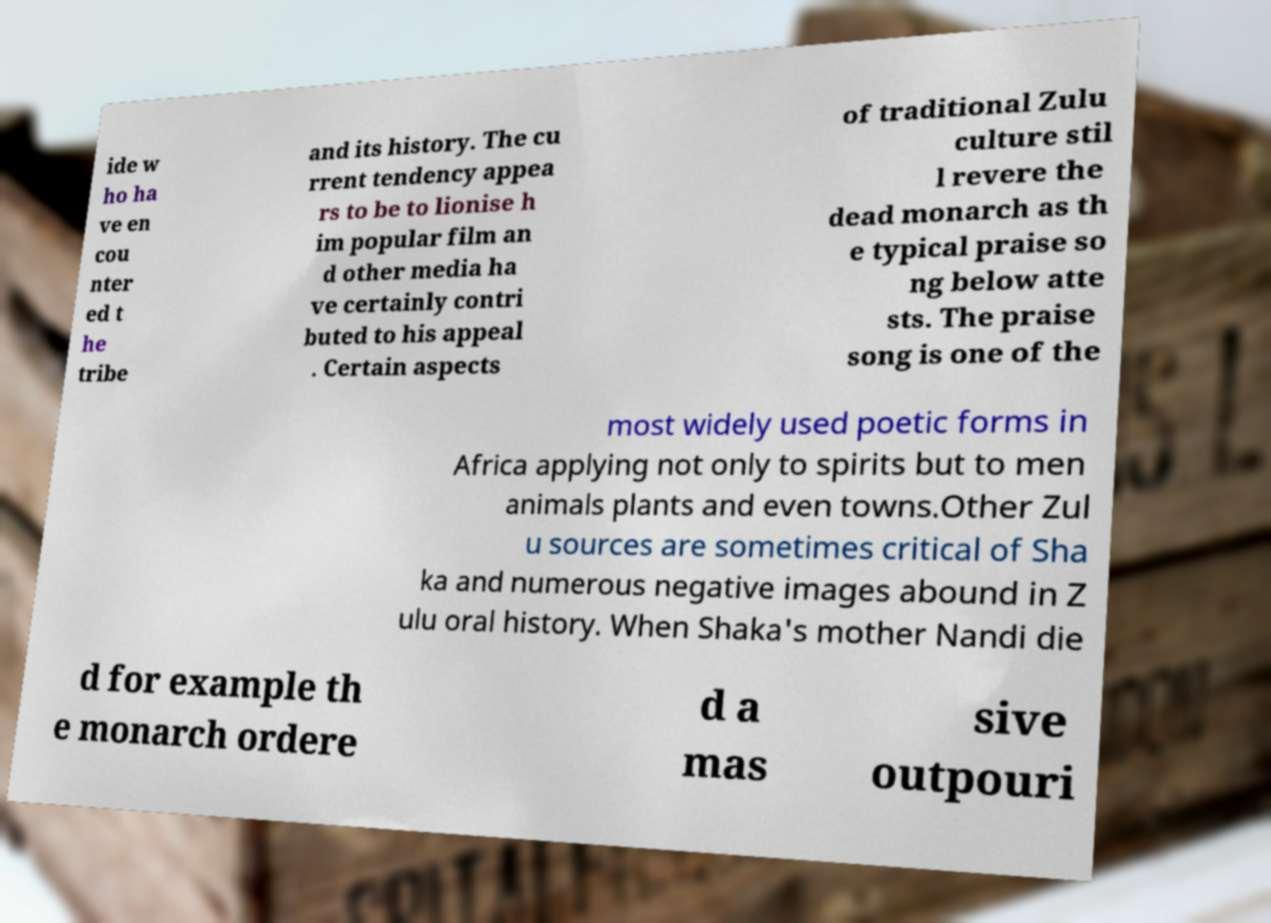There's text embedded in this image that I need extracted. Can you transcribe it verbatim? ide w ho ha ve en cou nter ed t he tribe and its history. The cu rrent tendency appea rs to be to lionise h im popular film an d other media ha ve certainly contri buted to his appeal . Certain aspects of traditional Zulu culture stil l revere the dead monarch as th e typical praise so ng below atte sts. The praise song is one of the most widely used poetic forms in Africa applying not only to spirits but to men animals plants and even towns.Other Zul u sources are sometimes critical of Sha ka and numerous negative images abound in Z ulu oral history. When Shaka's mother Nandi die d for example th e monarch ordere d a mas sive outpouri 